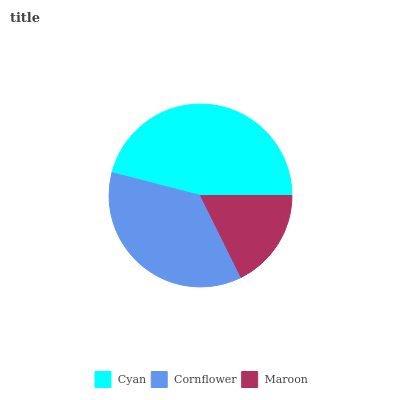Is Maroon the minimum?
Answer yes or no. Yes. Is Cyan the maximum?
Answer yes or no. Yes. Is Cornflower the minimum?
Answer yes or no. No. Is Cornflower the maximum?
Answer yes or no. No. Is Cyan greater than Cornflower?
Answer yes or no. Yes. Is Cornflower less than Cyan?
Answer yes or no. Yes. Is Cornflower greater than Cyan?
Answer yes or no. No. Is Cyan less than Cornflower?
Answer yes or no. No. Is Cornflower the high median?
Answer yes or no. Yes. Is Cornflower the low median?
Answer yes or no. Yes. Is Cyan the high median?
Answer yes or no. No. Is Maroon the low median?
Answer yes or no. No. 